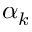Convert formula to latex. <formula><loc_0><loc_0><loc_500><loc_500>\alpha _ { k }</formula> 